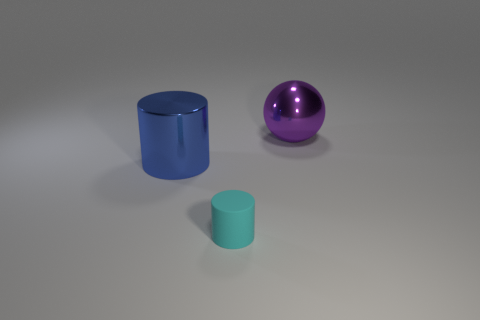Add 3 large rubber things. How many objects exist? 6 Subtract all balls. How many objects are left? 2 Subtract all purple objects. Subtract all small cyan matte things. How many objects are left? 1 Add 1 small objects. How many small objects are left? 2 Add 2 metal cylinders. How many metal cylinders exist? 3 Subtract 0 brown cubes. How many objects are left? 3 